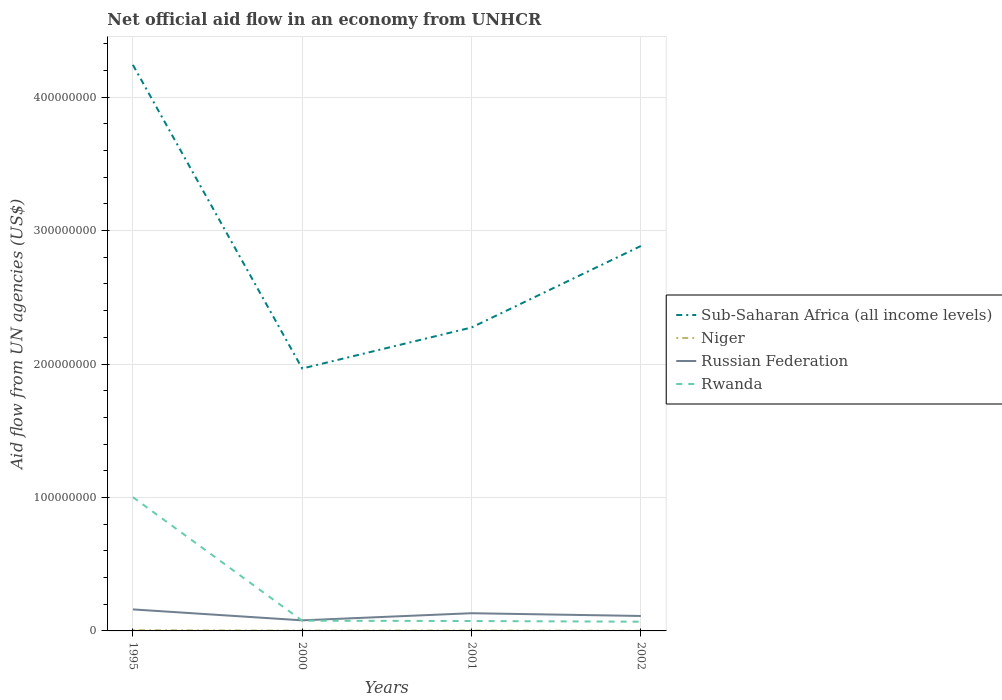Does the line corresponding to Sub-Saharan Africa (all income levels) intersect with the line corresponding to Rwanda?
Your answer should be very brief. No. Is the number of lines equal to the number of legend labels?
Ensure brevity in your answer.  Yes. Across all years, what is the maximum net official aid flow in Rwanda?
Offer a very short reply. 6.90e+06. What is the total net official aid flow in Niger in the graph?
Make the answer very short. 4.10e+05. What is the difference between the highest and the second highest net official aid flow in Russian Federation?
Offer a very short reply. 8.19e+06. Is the net official aid flow in Sub-Saharan Africa (all income levels) strictly greater than the net official aid flow in Rwanda over the years?
Offer a very short reply. No. How many lines are there?
Your response must be concise. 4. What is the difference between two consecutive major ticks on the Y-axis?
Ensure brevity in your answer.  1.00e+08. Does the graph contain any zero values?
Make the answer very short. No. Does the graph contain grids?
Provide a succinct answer. Yes. Where does the legend appear in the graph?
Give a very brief answer. Center right. How many legend labels are there?
Ensure brevity in your answer.  4. How are the legend labels stacked?
Keep it short and to the point. Vertical. What is the title of the graph?
Your response must be concise. Net official aid flow in an economy from UNHCR. What is the label or title of the Y-axis?
Keep it short and to the point. Aid flow from UN agencies (US$). What is the Aid flow from UN agencies (US$) in Sub-Saharan Africa (all income levels) in 1995?
Your answer should be compact. 4.24e+08. What is the Aid flow from UN agencies (US$) in Niger in 1995?
Provide a short and direct response. 5.10e+05. What is the Aid flow from UN agencies (US$) of Russian Federation in 1995?
Offer a terse response. 1.61e+07. What is the Aid flow from UN agencies (US$) of Rwanda in 1995?
Ensure brevity in your answer.  1.00e+08. What is the Aid flow from UN agencies (US$) in Sub-Saharan Africa (all income levels) in 2000?
Give a very brief answer. 1.97e+08. What is the Aid flow from UN agencies (US$) in Niger in 2000?
Your answer should be compact. 2.00e+05. What is the Aid flow from UN agencies (US$) in Russian Federation in 2000?
Keep it short and to the point. 7.93e+06. What is the Aid flow from UN agencies (US$) of Rwanda in 2000?
Keep it short and to the point. 7.65e+06. What is the Aid flow from UN agencies (US$) in Sub-Saharan Africa (all income levels) in 2001?
Ensure brevity in your answer.  2.27e+08. What is the Aid flow from UN agencies (US$) of Russian Federation in 2001?
Offer a very short reply. 1.33e+07. What is the Aid flow from UN agencies (US$) in Rwanda in 2001?
Your answer should be compact. 7.43e+06. What is the Aid flow from UN agencies (US$) of Sub-Saharan Africa (all income levels) in 2002?
Provide a short and direct response. 2.88e+08. What is the Aid flow from UN agencies (US$) in Niger in 2002?
Provide a succinct answer. 1.00e+05. What is the Aid flow from UN agencies (US$) in Russian Federation in 2002?
Make the answer very short. 1.12e+07. What is the Aid flow from UN agencies (US$) in Rwanda in 2002?
Offer a very short reply. 6.90e+06. Across all years, what is the maximum Aid flow from UN agencies (US$) in Sub-Saharan Africa (all income levels)?
Provide a succinct answer. 4.24e+08. Across all years, what is the maximum Aid flow from UN agencies (US$) in Niger?
Provide a short and direct response. 5.10e+05. Across all years, what is the maximum Aid flow from UN agencies (US$) in Russian Federation?
Provide a succinct answer. 1.61e+07. Across all years, what is the maximum Aid flow from UN agencies (US$) of Rwanda?
Ensure brevity in your answer.  1.00e+08. Across all years, what is the minimum Aid flow from UN agencies (US$) in Sub-Saharan Africa (all income levels)?
Offer a very short reply. 1.97e+08. Across all years, what is the minimum Aid flow from UN agencies (US$) of Russian Federation?
Provide a succinct answer. 7.93e+06. Across all years, what is the minimum Aid flow from UN agencies (US$) of Rwanda?
Provide a succinct answer. 6.90e+06. What is the total Aid flow from UN agencies (US$) of Sub-Saharan Africa (all income levels) in the graph?
Keep it short and to the point. 1.14e+09. What is the total Aid flow from UN agencies (US$) in Niger in the graph?
Make the answer very short. 1.10e+06. What is the total Aid flow from UN agencies (US$) in Russian Federation in the graph?
Ensure brevity in your answer.  4.85e+07. What is the total Aid flow from UN agencies (US$) of Rwanda in the graph?
Make the answer very short. 1.22e+08. What is the difference between the Aid flow from UN agencies (US$) of Sub-Saharan Africa (all income levels) in 1995 and that in 2000?
Provide a short and direct response. 2.28e+08. What is the difference between the Aid flow from UN agencies (US$) in Russian Federation in 1995 and that in 2000?
Your answer should be compact. 8.19e+06. What is the difference between the Aid flow from UN agencies (US$) of Rwanda in 1995 and that in 2000?
Your answer should be compact. 9.26e+07. What is the difference between the Aid flow from UN agencies (US$) in Sub-Saharan Africa (all income levels) in 1995 and that in 2001?
Your answer should be compact. 1.97e+08. What is the difference between the Aid flow from UN agencies (US$) of Russian Federation in 1995 and that in 2001?
Make the answer very short. 2.85e+06. What is the difference between the Aid flow from UN agencies (US$) of Rwanda in 1995 and that in 2001?
Your response must be concise. 9.28e+07. What is the difference between the Aid flow from UN agencies (US$) in Sub-Saharan Africa (all income levels) in 1995 and that in 2002?
Your answer should be very brief. 1.36e+08. What is the difference between the Aid flow from UN agencies (US$) of Russian Federation in 1995 and that in 2002?
Keep it short and to the point. 4.91e+06. What is the difference between the Aid flow from UN agencies (US$) in Rwanda in 1995 and that in 2002?
Give a very brief answer. 9.33e+07. What is the difference between the Aid flow from UN agencies (US$) in Sub-Saharan Africa (all income levels) in 2000 and that in 2001?
Give a very brief answer. -3.07e+07. What is the difference between the Aid flow from UN agencies (US$) in Niger in 2000 and that in 2001?
Offer a terse response. -9.00e+04. What is the difference between the Aid flow from UN agencies (US$) in Russian Federation in 2000 and that in 2001?
Your answer should be very brief. -5.34e+06. What is the difference between the Aid flow from UN agencies (US$) of Rwanda in 2000 and that in 2001?
Your answer should be compact. 2.20e+05. What is the difference between the Aid flow from UN agencies (US$) in Sub-Saharan Africa (all income levels) in 2000 and that in 2002?
Offer a terse response. -9.18e+07. What is the difference between the Aid flow from UN agencies (US$) of Niger in 2000 and that in 2002?
Provide a short and direct response. 1.00e+05. What is the difference between the Aid flow from UN agencies (US$) of Russian Federation in 2000 and that in 2002?
Your answer should be very brief. -3.28e+06. What is the difference between the Aid flow from UN agencies (US$) in Rwanda in 2000 and that in 2002?
Provide a succinct answer. 7.50e+05. What is the difference between the Aid flow from UN agencies (US$) in Sub-Saharan Africa (all income levels) in 2001 and that in 2002?
Keep it short and to the point. -6.11e+07. What is the difference between the Aid flow from UN agencies (US$) of Russian Federation in 2001 and that in 2002?
Offer a terse response. 2.06e+06. What is the difference between the Aid flow from UN agencies (US$) in Rwanda in 2001 and that in 2002?
Give a very brief answer. 5.30e+05. What is the difference between the Aid flow from UN agencies (US$) of Sub-Saharan Africa (all income levels) in 1995 and the Aid flow from UN agencies (US$) of Niger in 2000?
Keep it short and to the point. 4.24e+08. What is the difference between the Aid flow from UN agencies (US$) of Sub-Saharan Africa (all income levels) in 1995 and the Aid flow from UN agencies (US$) of Russian Federation in 2000?
Your answer should be very brief. 4.16e+08. What is the difference between the Aid flow from UN agencies (US$) in Sub-Saharan Africa (all income levels) in 1995 and the Aid flow from UN agencies (US$) in Rwanda in 2000?
Provide a short and direct response. 4.17e+08. What is the difference between the Aid flow from UN agencies (US$) of Niger in 1995 and the Aid flow from UN agencies (US$) of Russian Federation in 2000?
Offer a very short reply. -7.42e+06. What is the difference between the Aid flow from UN agencies (US$) of Niger in 1995 and the Aid flow from UN agencies (US$) of Rwanda in 2000?
Offer a terse response. -7.14e+06. What is the difference between the Aid flow from UN agencies (US$) in Russian Federation in 1995 and the Aid flow from UN agencies (US$) in Rwanda in 2000?
Offer a very short reply. 8.47e+06. What is the difference between the Aid flow from UN agencies (US$) in Sub-Saharan Africa (all income levels) in 1995 and the Aid flow from UN agencies (US$) in Niger in 2001?
Ensure brevity in your answer.  4.24e+08. What is the difference between the Aid flow from UN agencies (US$) in Sub-Saharan Africa (all income levels) in 1995 and the Aid flow from UN agencies (US$) in Russian Federation in 2001?
Give a very brief answer. 4.11e+08. What is the difference between the Aid flow from UN agencies (US$) of Sub-Saharan Africa (all income levels) in 1995 and the Aid flow from UN agencies (US$) of Rwanda in 2001?
Ensure brevity in your answer.  4.17e+08. What is the difference between the Aid flow from UN agencies (US$) of Niger in 1995 and the Aid flow from UN agencies (US$) of Russian Federation in 2001?
Offer a very short reply. -1.28e+07. What is the difference between the Aid flow from UN agencies (US$) in Niger in 1995 and the Aid flow from UN agencies (US$) in Rwanda in 2001?
Offer a terse response. -6.92e+06. What is the difference between the Aid flow from UN agencies (US$) of Russian Federation in 1995 and the Aid flow from UN agencies (US$) of Rwanda in 2001?
Provide a short and direct response. 8.69e+06. What is the difference between the Aid flow from UN agencies (US$) of Sub-Saharan Africa (all income levels) in 1995 and the Aid flow from UN agencies (US$) of Niger in 2002?
Your answer should be very brief. 4.24e+08. What is the difference between the Aid flow from UN agencies (US$) of Sub-Saharan Africa (all income levels) in 1995 and the Aid flow from UN agencies (US$) of Russian Federation in 2002?
Offer a terse response. 4.13e+08. What is the difference between the Aid flow from UN agencies (US$) of Sub-Saharan Africa (all income levels) in 1995 and the Aid flow from UN agencies (US$) of Rwanda in 2002?
Your response must be concise. 4.17e+08. What is the difference between the Aid flow from UN agencies (US$) in Niger in 1995 and the Aid flow from UN agencies (US$) in Russian Federation in 2002?
Provide a succinct answer. -1.07e+07. What is the difference between the Aid flow from UN agencies (US$) in Niger in 1995 and the Aid flow from UN agencies (US$) in Rwanda in 2002?
Provide a succinct answer. -6.39e+06. What is the difference between the Aid flow from UN agencies (US$) in Russian Federation in 1995 and the Aid flow from UN agencies (US$) in Rwanda in 2002?
Your response must be concise. 9.22e+06. What is the difference between the Aid flow from UN agencies (US$) of Sub-Saharan Africa (all income levels) in 2000 and the Aid flow from UN agencies (US$) of Niger in 2001?
Offer a very short reply. 1.96e+08. What is the difference between the Aid flow from UN agencies (US$) of Sub-Saharan Africa (all income levels) in 2000 and the Aid flow from UN agencies (US$) of Russian Federation in 2001?
Offer a very short reply. 1.83e+08. What is the difference between the Aid flow from UN agencies (US$) in Sub-Saharan Africa (all income levels) in 2000 and the Aid flow from UN agencies (US$) in Rwanda in 2001?
Provide a short and direct response. 1.89e+08. What is the difference between the Aid flow from UN agencies (US$) of Niger in 2000 and the Aid flow from UN agencies (US$) of Russian Federation in 2001?
Make the answer very short. -1.31e+07. What is the difference between the Aid flow from UN agencies (US$) in Niger in 2000 and the Aid flow from UN agencies (US$) in Rwanda in 2001?
Your answer should be compact. -7.23e+06. What is the difference between the Aid flow from UN agencies (US$) in Russian Federation in 2000 and the Aid flow from UN agencies (US$) in Rwanda in 2001?
Keep it short and to the point. 5.00e+05. What is the difference between the Aid flow from UN agencies (US$) in Sub-Saharan Africa (all income levels) in 2000 and the Aid flow from UN agencies (US$) in Niger in 2002?
Offer a very short reply. 1.97e+08. What is the difference between the Aid flow from UN agencies (US$) in Sub-Saharan Africa (all income levels) in 2000 and the Aid flow from UN agencies (US$) in Russian Federation in 2002?
Ensure brevity in your answer.  1.85e+08. What is the difference between the Aid flow from UN agencies (US$) of Sub-Saharan Africa (all income levels) in 2000 and the Aid flow from UN agencies (US$) of Rwanda in 2002?
Offer a terse response. 1.90e+08. What is the difference between the Aid flow from UN agencies (US$) of Niger in 2000 and the Aid flow from UN agencies (US$) of Russian Federation in 2002?
Give a very brief answer. -1.10e+07. What is the difference between the Aid flow from UN agencies (US$) in Niger in 2000 and the Aid flow from UN agencies (US$) in Rwanda in 2002?
Provide a succinct answer. -6.70e+06. What is the difference between the Aid flow from UN agencies (US$) of Russian Federation in 2000 and the Aid flow from UN agencies (US$) of Rwanda in 2002?
Provide a short and direct response. 1.03e+06. What is the difference between the Aid flow from UN agencies (US$) in Sub-Saharan Africa (all income levels) in 2001 and the Aid flow from UN agencies (US$) in Niger in 2002?
Your answer should be very brief. 2.27e+08. What is the difference between the Aid flow from UN agencies (US$) in Sub-Saharan Africa (all income levels) in 2001 and the Aid flow from UN agencies (US$) in Russian Federation in 2002?
Offer a terse response. 2.16e+08. What is the difference between the Aid flow from UN agencies (US$) in Sub-Saharan Africa (all income levels) in 2001 and the Aid flow from UN agencies (US$) in Rwanda in 2002?
Give a very brief answer. 2.20e+08. What is the difference between the Aid flow from UN agencies (US$) in Niger in 2001 and the Aid flow from UN agencies (US$) in Russian Federation in 2002?
Provide a succinct answer. -1.09e+07. What is the difference between the Aid flow from UN agencies (US$) in Niger in 2001 and the Aid flow from UN agencies (US$) in Rwanda in 2002?
Give a very brief answer. -6.61e+06. What is the difference between the Aid flow from UN agencies (US$) in Russian Federation in 2001 and the Aid flow from UN agencies (US$) in Rwanda in 2002?
Make the answer very short. 6.37e+06. What is the average Aid flow from UN agencies (US$) in Sub-Saharan Africa (all income levels) per year?
Your response must be concise. 2.84e+08. What is the average Aid flow from UN agencies (US$) of Niger per year?
Your answer should be very brief. 2.75e+05. What is the average Aid flow from UN agencies (US$) in Russian Federation per year?
Give a very brief answer. 1.21e+07. What is the average Aid flow from UN agencies (US$) of Rwanda per year?
Offer a very short reply. 3.06e+07. In the year 1995, what is the difference between the Aid flow from UN agencies (US$) in Sub-Saharan Africa (all income levels) and Aid flow from UN agencies (US$) in Niger?
Offer a very short reply. 4.24e+08. In the year 1995, what is the difference between the Aid flow from UN agencies (US$) of Sub-Saharan Africa (all income levels) and Aid flow from UN agencies (US$) of Russian Federation?
Provide a short and direct response. 4.08e+08. In the year 1995, what is the difference between the Aid flow from UN agencies (US$) in Sub-Saharan Africa (all income levels) and Aid flow from UN agencies (US$) in Rwanda?
Provide a short and direct response. 3.24e+08. In the year 1995, what is the difference between the Aid flow from UN agencies (US$) in Niger and Aid flow from UN agencies (US$) in Russian Federation?
Provide a short and direct response. -1.56e+07. In the year 1995, what is the difference between the Aid flow from UN agencies (US$) in Niger and Aid flow from UN agencies (US$) in Rwanda?
Offer a very short reply. -9.97e+07. In the year 1995, what is the difference between the Aid flow from UN agencies (US$) in Russian Federation and Aid flow from UN agencies (US$) in Rwanda?
Ensure brevity in your answer.  -8.41e+07. In the year 2000, what is the difference between the Aid flow from UN agencies (US$) in Sub-Saharan Africa (all income levels) and Aid flow from UN agencies (US$) in Niger?
Keep it short and to the point. 1.96e+08. In the year 2000, what is the difference between the Aid flow from UN agencies (US$) in Sub-Saharan Africa (all income levels) and Aid flow from UN agencies (US$) in Russian Federation?
Ensure brevity in your answer.  1.89e+08. In the year 2000, what is the difference between the Aid flow from UN agencies (US$) of Sub-Saharan Africa (all income levels) and Aid flow from UN agencies (US$) of Rwanda?
Offer a very short reply. 1.89e+08. In the year 2000, what is the difference between the Aid flow from UN agencies (US$) in Niger and Aid flow from UN agencies (US$) in Russian Federation?
Your response must be concise. -7.73e+06. In the year 2000, what is the difference between the Aid flow from UN agencies (US$) in Niger and Aid flow from UN agencies (US$) in Rwanda?
Your response must be concise. -7.45e+06. In the year 2001, what is the difference between the Aid flow from UN agencies (US$) of Sub-Saharan Africa (all income levels) and Aid flow from UN agencies (US$) of Niger?
Give a very brief answer. 2.27e+08. In the year 2001, what is the difference between the Aid flow from UN agencies (US$) in Sub-Saharan Africa (all income levels) and Aid flow from UN agencies (US$) in Russian Federation?
Offer a very short reply. 2.14e+08. In the year 2001, what is the difference between the Aid flow from UN agencies (US$) in Sub-Saharan Africa (all income levels) and Aid flow from UN agencies (US$) in Rwanda?
Ensure brevity in your answer.  2.20e+08. In the year 2001, what is the difference between the Aid flow from UN agencies (US$) in Niger and Aid flow from UN agencies (US$) in Russian Federation?
Keep it short and to the point. -1.30e+07. In the year 2001, what is the difference between the Aid flow from UN agencies (US$) in Niger and Aid flow from UN agencies (US$) in Rwanda?
Provide a succinct answer. -7.14e+06. In the year 2001, what is the difference between the Aid flow from UN agencies (US$) in Russian Federation and Aid flow from UN agencies (US$) in Rwanda?
Your response must be concise. 5.84e+06. In the year 2002, what is the difference between the Aid flow from UN agencies (US$) of Sub-Saharan Africa (all income levels) and Aid flow from UN agencies (US$) of Niger?
Your answer should be compact. 2.88e+08. In the year 2002, what is the difference between the Aid flow from UN agencies (US$) in Sub-Saharan Africa (all income levels) and Aid flow from UN agencies (US$) in Russian Federation?
Your answer should be compact. 2.77e+08. In the year 2002, what is the difference between the Aid flow from UN agencies (US$) of Sub-Saharan Africa (all income levels) and Aid flow from UN agencies (US$) of Rwanda?
Your answer should be compact. 2.82e+08. In the year 2002, what is the difference between the Aid flow from UN agencies (US$) of Niger and Aid flow from UN agencies (US$) of Russian Federation?
Your answer should be very brief. -1.11e+07. In the year 2002, what is the difference between the Aid flow from UN agencies (US$) in Niger and Aid flow from UN agencies (US$) in Rwanda?
Ensure brevity in your answer.  -6.80e+06. In the year 2002, what is the difference between the Aid flow from UN agencies (US$) of Russian Federation and Aid flow from UN agencies (US$) of Rwanda?
Give a very brief answer. 4.31e+06. What is the ratio of the Aid flow from UN agencies (US$) in Sub-Saharan Africa (all income levels) in 1995 to that in 2000?
Your answer should be compact. 2.16. What is the ratio of the Aid flow from UN agencies (US$) in Niger in 1995 to that in 2000?
Your answer should be very brief. 2.55. What is the ratio of the Aid flow from UN agencies (US$) in Russian Federation in 1995 to that in 2000?
Offer a terse response. 2.03. What is the ratio of the Aid flow from UN agencies (US$) in Rwanda in 1995 to that in 2000?
Provide a succinct answer. 13.1. What is the ratio of the Aid flow from UN agencies (US$) of Sub-Saharan Africa (all income levels) in 1995 to that in 2001?
Your response must be concise. 1.87. What is the ratio of the Aid flow from UN agencies (US$) in Niger in 1995 to that in 2001?
Provide a succinct answer. 1.76. What is the ratio of the Aid flow from UN agencies (US$) in Russian Federation in 1995 to that in 2001?
Give a very brief answer. 1.21. What is the ratio of the Aid flow from UN agencies (US$) of Rwanda in 1995 to that in 2001?
Give a very brief answer. 13.49. What is the ratio of the Aid flow from UN agencies (US$) of Sub-Saharan Africa (all income levels) in 1995 to that in 2002?
Your answer should be compact. 1.47. What is the ratio of the Aid flow from UN agencies (US$) in Niger in 1995 to that in 2002?
Provide a short and direct response. 5.1. What is the ratio of the Aid flow from UN agencies (US$) in Russian Federation in 1995 to that in 2002?
Ensure brevity in your answer.  1.44. What is the ratio of the Aid flow from UN agencies (US$) in Rwanda in 1995 to that in 2002?
Offer a very short reply. 14.53. What is the ratio of the Aid flow from UN agencies (US$) in Sub-Saharan Africa (all income levels) in 2000 to that in 2001?
Provide a succinct answer. 0.86. What is the ratio of the Aid flow from UN agencies (US$) of Niger in 2000 to that in 2001?
Keep it short and to the point. 0.69. What is the ratio of the Aid flow from UN agencies (US$) in Russian Federation in 2000 to that in 2001?
Provide a succinct answer. 0.6. What is the ratio of the Aid flow from UN agencies (US$) in Rwanda in 2000 to that in 2001?
Offer a terse response. 1.03. What is the ratio of the Aid flow from UN agencies (US$) of Sub-Saharan Africa (all income levels) in 2000 to that in 2002?
Offer a terse response. 0.68. What is the ratio of the Aid flow from UN agencies (US$) of Niger in 2000 to that in 2002?
Keep it short and to the point. 2. What is the ratio of the Aid flow from UN agencies (US$) in Russian Federation in 2000 to that in 2002?
Provide a succinct answer. 0.71. What is the ratio of the Aid flow from UN agencies (US$) in Rwanda in 2000 to that in 2002?
Keep it short and to the point. 1.11. What is the ratio of the Aid flow from UN agencies (US$) in Sub-Saharan Africa (all income levels) in 2001 to that in 2002?
Provide a succinct answer. 0.79. What is the ratio of the Aid flow from UN agencies (US$) in Niger in 2001 to that in 2002?
Give a very brief answer. 2.9. What is the ratio of the Aid flow from UN agencies (US$) of Russian Federation in 2001 to that in 2002?
Offer a terse response. 1.18. What is the ratio of the Aid flow from UN agencies (US$) in Rwanda in 2001 to that in 2002?
Your response must be concise. 1.08. What is the difference between the highest and the second highest Aid flow from UN agencies (US$) of Sub-Saharan Africa (all income levels)?
Ensure brevity in your answer.  1.36e+08. What is the difference between the highest and the second highest Aid flow from UN agencies (US$) in Russian Federation?
Offer a terse response. 2.85e+06. What is the difference between the highest and the second highest Aid flow from UN agencies (US$) of Rwanda?
Your response must be concise. 9.26e+07. What is the difference between the highest and the lowest Aid flow from UN agencies (US$) in Sub-Saharan Africa (all income levels)?
Your answer should be very brief. 2.28e+08. What is the difference between the highest and the lowest Aid flow from UN agencies (US$) in Niger?
Provide a succinct answer. 4.10e+05. What is the difference between the highest and the lowest Aid flow from UN agencies (US$) in Russian Federation?
Your response must be concise. 8.19e+06. What is the difference between the highest and the lowest Aid flow from UN agencies (US$) of Rwanda?
Your answer should be very brief. 9.33e+07. 